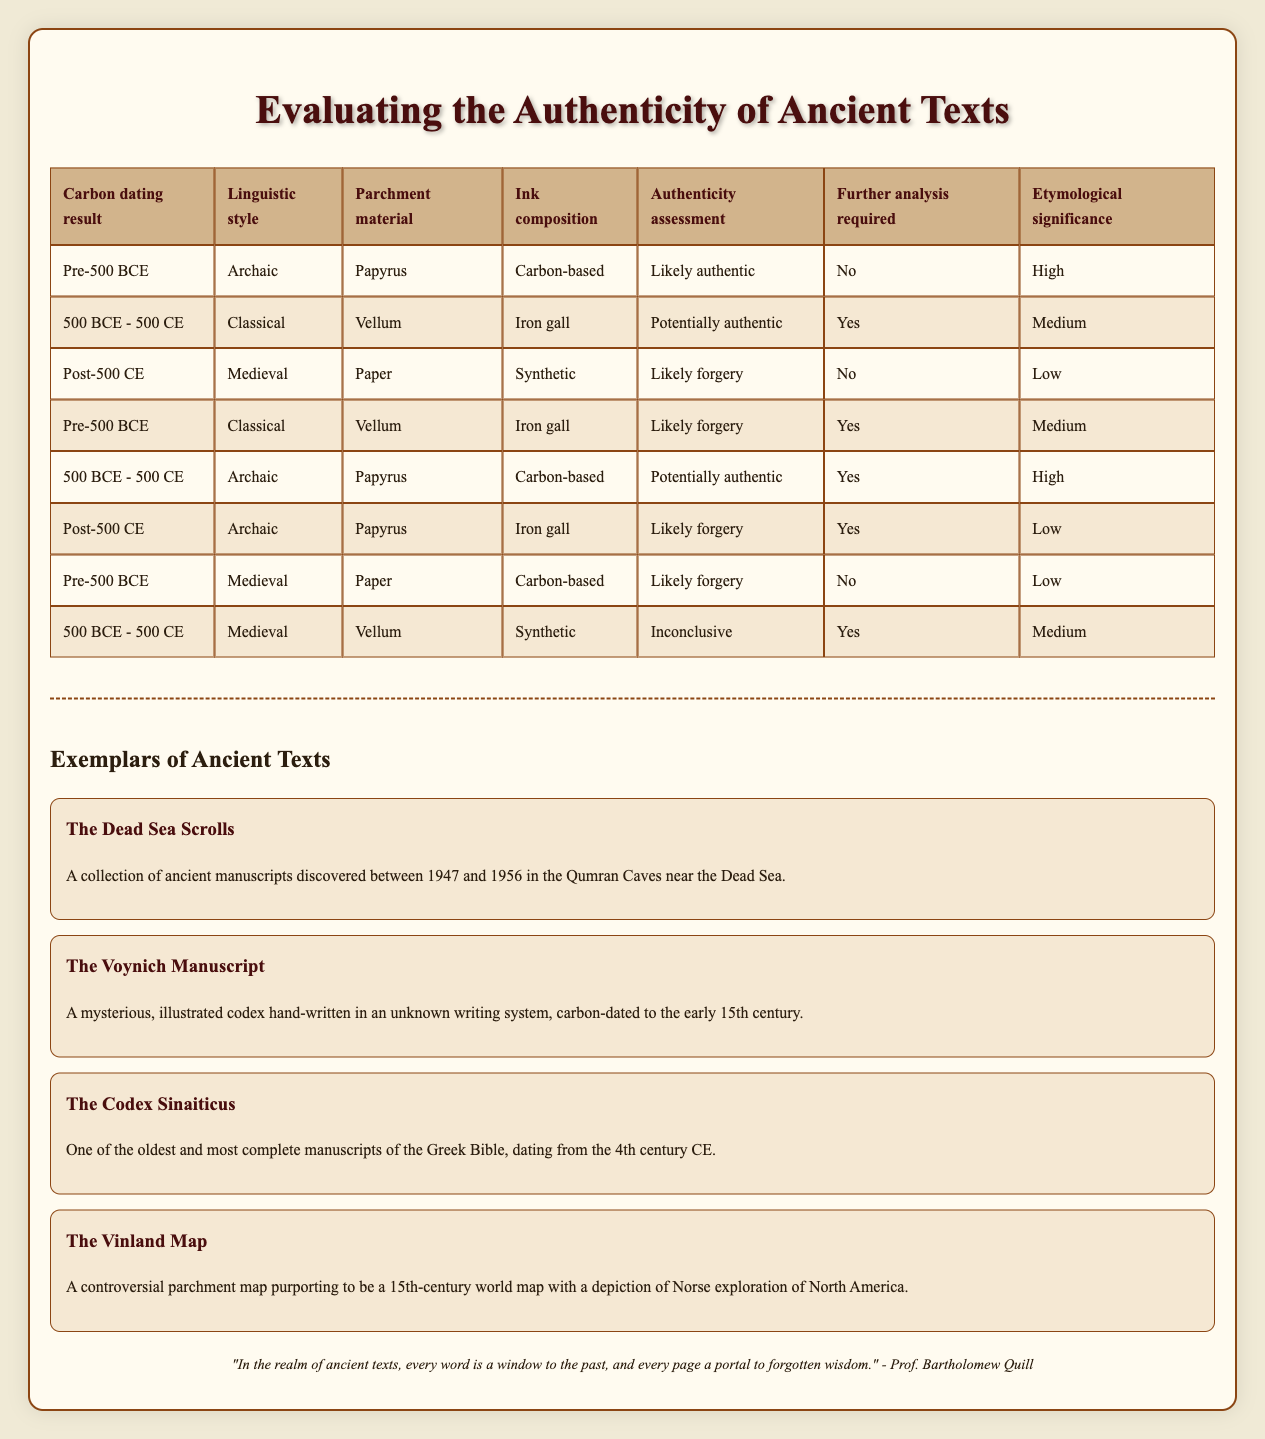What is the authenticity assessment for texts carbon-dated between 500 BCE and 500 CE with a classical linguistic style, vellum parchment, and iron gall ink composition? According to the table, for the conditions stated (500 BCE - 500 CE, Classical, Vellum, Iron gall), the authenticity assessment is "Potentially authentic." This can be found directly by locating the corresponding row in the table.
Answer: Potentially authentic How many conditions indicate a likely forgery? To find this, I will count the rows in the table that have "Likely forgery" listed as the authenticity assessment. There are three rows that match this condition.
Answer: 3 Does any entry indicate that further analysis is required when the parchment is made of papyrus? By examining the rows where the parchment material is "Papyrus," we see two instances: one for "Pre-500 BCE" with carbon-based ink (which requires no further analysis) and the other for "500 BCE - 500 CE" with archaic style (which requires further analysis). Therefore, yes, there is an instance that indicates further analysis is required.
Answer: Yes What is the etymological significance associated with texts that are likely authentic? By observing every row that has the authenticity assessment of "Likely authentic," we find two cases. The first one has a high significance and the second one does not exist, leading to a conclusion: the average etymological significance is high when texts are considered likely authentic.
Answer: High If a text has a medieval linguistic style and uses synthetic ink on vellum parchment, what is the authenticity assessment? From the table, for the conditions of "Post-500 CE," "Medieval," "Vellum," and "Synthetic," the authenticity assessment given is "Inconclusive." I extracted this information from the provided data in the respective row of the table.
Answer: Inconclusive 